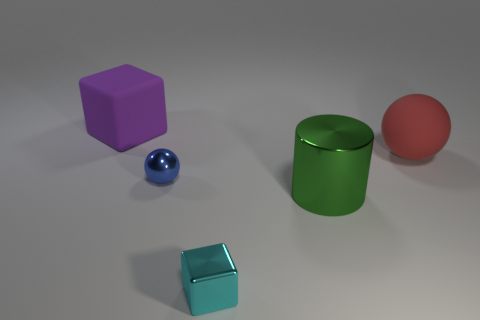Add 3 blue balls. How many objects exist? 8 Subtract all cylinders. How many objects are left? 4 Subtract 0 blue cylinders. How many objects are left? 5 Subtract all green metallic cylinders. Subtract all big brown matte balls. How many objects are left? 4 Add 4 tiny objects. How many tiny objects are left? 6 Add 4 large red spheres. How many large red spheres exist? 5 